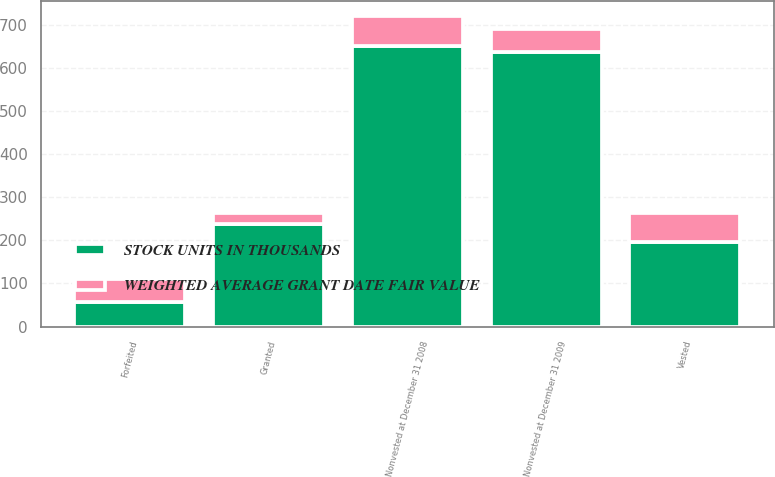<chart> <loc_0><loc_0><loc_500><loc_500><stacked_bar_chart><ecel><fcel>Nonvested at December 31 2008<fcel>Granted<fcel>Vested<fcel>Forfeited<fcel>Nonvested at December 31 2009<nl><fcel>STOCK UNITS IN THOUSANDS<fcel>651<fcel>238<fcel>195<fcel>57<fcel>637<nl><fcel>WEIGHTED AVERAGE GRANT DATE FAIR VALUE<fcel>67.9<fcel>25.41<fcel>68.75<fcel>52.57<fcel>53.06<nl></chart> 